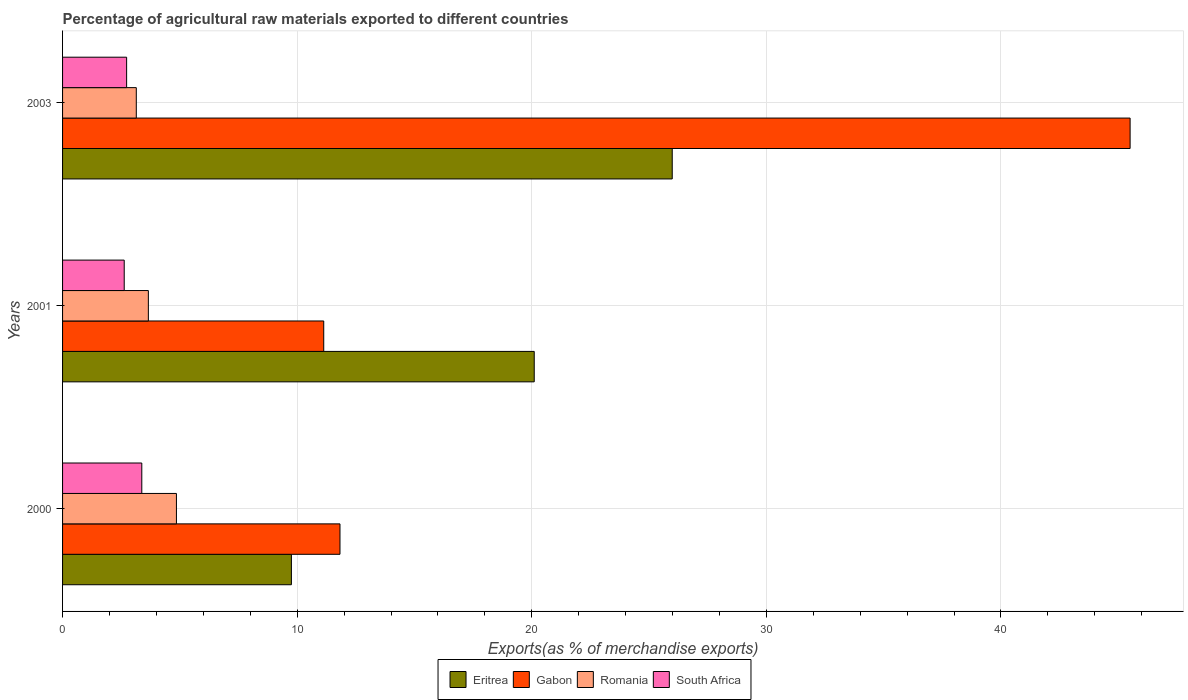How many groups of bars are there?
Give a very brief answer. 3. How many bars are there on the 1st tick from the top?
Your answer should be very brief. 4. How many bars are there on the 1st tick from the bottom?
Offer a very short reply. 4. What is the label of the 3rd group of bars from the top?
Offer a terse response. 2000. In how many cases, is the number of bars for a given year not equal to the number of legend labels?
Offer a very short reply. 0. What is the percentage of exports to different countries in Eritrea in 2000?
Keep it short and to the point. 9.75. Across all years, what is the maximum percentage of exports to different countries in Eritrea?
Keep it short and to the point. 25.99. Across all years, what is the minimum percentage of exports to different countries in Romania?
Ensure brevity in your answer.  3.14. In which year was the percentage of exports to different countries in South Africa minimum?
Your answer should be very brief. 2001. What is the total percentage of exports to different countries in Romania in the graph?
Make the answer very short. 11.65. What is the difference between the percentage of exports to different countries in Romania in 2000 and that in 2003?
Ensure brevity in your answer.  1.71. What is the difference between the percentage of exports to different countries in Eritrea in 2001 and the percentage of exports to different countries in South Africa in 2003?
Provide a short and direct response. 17.37. What is the average percentage of exports to different countries in South Africa per year?
Make the answer very short. 2.91. In the year 2003, what is the difference between the percentage of exports to different countries in Romania and percentage of exports to different countries in Gabon?
Make the answer very short. -42.36. In how many years, is the percentage of exports to different countries in Eritrea greater than 40 %?
Give a very brief answer. 0. What is the ratio of the percentage of exports to different countries in Eritrea in 2001 to that in 2003?
Your answer should be compact. 0.77. Is the percentage of exports to different countries in Romania in 2001 less than that in 2003?
Keep it short and to the point. No. What is the difference between the highest and the second highest percentage of exports to different countries in Romania?
Offer a very short reply. 1.2. What is the difference between the highest and the lowest percentage of exports to different countries in Gabon?
Ensure brevity in your answer.  34.37. Is the sum of the percentage of exports to different countries in Eritrea in 2000 and 2001 greater than the maximum percentage of exports to different countries in Romania across all years?
Give a very brief answer. Yes. Is it the case that in every year, the sum of the percentage of exports to different countries in Eritrea and percentage of exports to different countries in South Africa is greater than the sum of percentage of exports to different countries in Gabon and percentage of exports to different countries in Romania?
Your response must be concise. No. What does the 4th bar from the top in 2000 represents?
Your answer should be very brief. Eritrea. What does the 4th bar from the bottom in 2003 represents?
Ensure brevity in your answer.  South Africa. Is it the case that in every year, the sum of the percentage of exports to different countries in South Africa and percentage of exports to different countries in Romania is greater than the percentage of exports to different countries in Eritrea?
Offer a terse response. No. How many bars are there?
Provide a short and direct response. 12. How many years are there in the graph?
Ensure brevity in your answer.  3. Where does the legend appear in the graph?
Provide a succinct answer. Bottom center. How many legend labels are there?
Your answer should be very brief. 4. What is the title of the graph?
Your answer should be compact. Percentage of agricultural raw materials exported to different countries. Does "Indonesia" appear as one of the legend labels in the graph?
Give a very brief answer. No. What is the label or title of the X-axis?
Offer a terse response. Exports(as % of merchandise exports). What is the label or title of the Y-axis?
Offer a very short reply. Years. What is the Exports(as % of merchandise exports) of Eritrea in 2000?
Keep it short and to the point. 9.75. What is the Exports(as % of merchandise exports) in Gabon in 2000?
Offer a very short reply. 11.82. What is the Exports(as % of merchandise exports) of Romania in 2000?
Your answer should be compact. 4.85. What is the Exports(as % of merchandise exports) of South Africa in 2000?
Provide a short and direct response. 3.38. What is the Exports(as % of merchandise exports) of Eritrea in 2001?
Your response must be concise. 20.1. What is the Exports(as % of merchandise exports) in Gabon in 2001?
Give a very brief answer. 11.13. What is the Exports(as % of merchandise exports) of Romania in 2001?
Keep it short and to the point. 3.66. What is the Exports(as % of merchandise exports) of South Africa in 2001?
Your answer should be very brief. 2.63. What is the Exports(as % of merchandise exports) of Eritrea in 2003?
Ensure brevity in your answer.  25.99. What is the Exports(as % of merchandise exports) in Gabon in 2003?
Ensure brevity in your answer.  45.5. What is the Exports(as % of merchandise exports) of Romania in 2003?
Provide a short and direct response. 3.14. What is the Exports(as % of merchandise exports) in South Africa in 2003?
Your response must be concise. 2.73. Across all years, what is the maximum Exports(as % of merchandise exports) of Eritrea?
Provide a succinct answer. 25.99. Across all years, what is the maximum Exports(as % of merchandise exports) of Gabon?
Keep it short and to the point. 45.5. Across all years, what is the maximum Exports(as % of merchandise exports) in Romania?
Provide a succinct answer. 4.85. Across all years, what is the maximum Exports(as % of merchandise exports) of South Africa?
Provide a short and direct response. 3.38. Across all years, what is the minimum Exports(as % of merchandise exports) in Eritrea?
Keep it short and to the point. 9.75. Across all years, what is the minimum Exports(as % of merchandise exports) of Gabon?
Provide a succinct answer. 11.13. Across all years, what is the minimum Exports(as % of merchandise exports) in Romania?
Give a very brief answer. 3.14. Across all years, what is the minimum Exports(as % of merchandise exports) in South Africa?
Give a very brief answer. 2.63. What is the total Exports(as % of merchandise exports) in Eritrea in the graph?
Your answer should be compact. 55.85. What is the total Exports(as % of merchandise exports) in Gabon in the graph?
Your response must be concise. 68.46. What is the total Exports(as % of merchandise exports) of Romania in the graph?
Ensure brevity in your answer.  11.65. What is the total Exports(as % of merchandise exports) of South Africa in the graph?
Give a very brief answer. 8.74. What is the difference between the Exports(as % of merchandise exports) in Eritrea in 2000 and that in 2001?
Give a very brief answer. -10.35. What is the difference between the Exports(as % of merchandise exports) of Gabon in 2000 and that in 2001?
Provide a short and direct response. 0.69. What is the difference between the Exports(as % of merchandise exports) in Romania in 2000 and that in 2001?
Offer a terse response. 1.2. What is the difference between the Exports(as % of merchandise exports) of South Africa in 2000 and that in 2001?
Make the answer very short. 0.75. What is the difference between the Exports(as % of merchandise exports) of Eritrea in 2000 and that in 2003?
Your answer should be very brief. -16.23. What is the difference between the Exports(as % of merchandise exports) of Gabon in 2000 and that in 2003?
Your response must be concise. -33.68. What is the difference between the Exports(as % of merchandise exports) of Romania in 2000 and that in 2003?
Keep it short and to the point. 1.71. What is the difference between the Exports(as % of merchandise exports) in South Africa in 2000 and that in 2003?
Give a very brief answer. 0.65. What is the difference between the Exports(as % of merchandise exports) in Eritrea in 2001 and that in 2003?
Ensure brevity in your answer.  -5.88. What is the difference between the Exports(as % of merchandise exports) of Gabon in 2001 and that in 2003?
Your answer should be compact. -34.37. What is the difference between the Exports(as % of merchandise exports) of Romania in 2001 and that in 2003?
Keep it short and to the point. 0.51. What is the difference between the Exports(as % of merchandise exports) of South Africa in 2001 and that in 2003?
Offer a terse response. -0.1. What is the difference between the Exports(as % of merchandise exports) in Eritrea in 2000 and the Exports(as % of merchandise exports) in Gabon in 2001?
Ensure brevity in your answer.  -1.38. What is the difference between the Exports(as % of merchandise exports) in Eritrea in 2000 and the Exports(as % of merchandise exports) in Romania in 2001?
Your answer should be very brief. 6.1. What is the difference between the Exports(as % of merchandise exports) in Eritrea in 2000 and the Exports(as % of merchandise exports) in South Africa in 2001?
Your response must be concise. 7.13. What is the difference between the Exports(as % of merchandise exports) in Gabon in 2000 and the Exports(as % of merchandise exports) in Romania in 2001?
Your response must be concise. 8.17. What is the difference between the Exports(as % of merchandise exports) of Gabon in 2000 and the Exports(as % of merchandise exports) of South Africa in 2001?
Ensure brevity in your answer.  9.2. What is the difference between the Exports(as % of merchandise exports) of Romania in 2000 and the Exports(as % of merchandise exports) of South Africa in 2001?
Offer a very short reply. 2.23. What is the difference between the Exports(as % of merchandise exports) in Eritrea in 2000 and the Exports(as % of merchandise exports) in Gabon in 2003?
Your response must be concise. -35.75. What is the difference between the Exports(as % of merchandise exports) of Eritrea in 2000 and the Exports(as % of merchandise exports) of Romania in 2003?
Your response must be concise. 6.61. What is the difference between the Exports(as % of merchandise exports) in Eritrea in 2000 and the Exports(as % of merchandise exports) in South Africa in 2003?
Make the answer very short. 7.02. What is the difference between the Exports(as % of merchandise exports) in Gabon in 2000 and the Exports(as % of merchandise exports) in Romania in 2003?
Keep it short and to the point. 8.68. What is the difference between the Exports(as % of merchandise exports) of Gabon in 2000 and the Exports(as % of merchandise exports) of South Africa in 2003?
Offer a terse response. 9.09. What is the difference between the Exports(as % of merchandise exports) in Romania in 2000 and the Exports(as % of merchandise exports) in South Africa in 2003?
Provide a short and direct response. 2.12. What is the difference between the Exports(as % of merchandise exports) of Eritrea in 2001 and the Exports(as % of merchandise exports) of Gabon in 2003?
Make the answer very short. -25.4. What is the difference between the Exports(as % of merchandise exports) in Eritrea in 2001 and the Exports(as % of merchandise exports) in Romania in 2003?
Offer a terse response. 16.96. What is the difference between the Exports(as % of merchandise exports) of Eritrea in 2001 and the Exports(as % of merchandise exports) of South Africa in 2003?
Offer a terse response. 17.37. What is the difference between the Exports(as % of merchandise exports) in Gabon in 2001 and the Exports(as % of merchandise exports) in Romania in 2003?
Provide a succinct answer. 7.99. What is the difference between the Exports(as % of merchandise exports) in Gabon in 2001 and the Exports(as % of merchandise exports) in South Africa in 2003?
Your answer should be compact. 8.4. What is the difference between the Exports(as % of merchandise exports) of Romania in 2001 and the Exports(as % of merchandise exports) of South Africa in 2003?
Keep it short and to the point. 0.93. What is the average Exports(as % of merchandise exports) of Eritrea per year?
Your response must be concise. 18.62. What is the average Exports(as % of merchandise exports) in Gabon per year?
Provide a succinct answer. 22.82. What is the average Exports(as % of merchandise exports) of Romania per year?
Make the answer very short. 3.88. What is the average Exports(as % of merchandise exports) in South Africa per year?
Give a very brief answer. 2.91. In the year 2000, what is the difference between the Exports(as % of merchandise exports) in Eritrea and Exports(as % of merchandise exports) in Gabon?
Provide a succinct answer. -2.07. In the year 2000, what is the difference between the Exports(as % of merchandise exports) of Eritrea and Exports(as % of merchandise exports) of Romania?
Make the answer very short. 4.9. In the year 2000, what is the difference between the Exports(as % of merchandise exports) of Eritrea and Exports(as % of merchandise exports) of South Africa?
Provide a short and direct response. 6.38. In the year 2000, what is the difference between the Exports(as % of merchandise exports) of Gabon and Exports(as % of merchandise exports) of Romania?
Provide a short and direct response. 6.97. In the year 2000, what is the difference between the Exports(as % of merchandise exports) in Gabon and Exports(as % of merchandise exports) in South Africa?
Ensure brevity in your answer.  8.45. In the year 2000, what is the difference between the Exports(as % of merchandise exports) in Romania and Exports(as % of merchandise exports) in South Africa?
Your response must be concise. 1.48. In the year 2001, what is the difference between the Exports(as % of merchandise exports) in Eritrea and Exports(as % of merchandise exports) in Gabon?
Your response must be concise. 8.97. In the year 2001, what is the difference between the Exports(as % of merchandise exports) of Eritrea and Exports(as % of merchandise exports) of Romania?
Keep it short and to the point. 16.45. In the year 2001, what is the difference between the Exports(as % of merchandise exports) of Eritrea and Exports(as % of merchandise exports) of South Africa?
Your response must be concise. 17.48. In the year 2001, what is the difference between the Exports(as % of merchandise exports) of Gabon and Exports(as % of merchandise exports) of Romania?
Offer a very short reply. 7.48. In the year 2001, what is the difference between the Exports(as % of merchandise exports) in Gabon and Exports(as % of merchandise exports) in South Africa?
Your response must be concise. 8.5. In the year 2001, what is the difference between the Exports(as % of merchandise exports) in Romania and Exports(as % of merchandise exports) in South Africa?
Your response must be concise. 1.03. In the year 2003, what is the difference between the Exports(as % of merchandise exports) in Eritrea and Exports(as % of merchandise exports) in Gabon?
Your answer should be compact. -19.52. In the year 2003, what is the difference between the Exports(as % of merchandise exports) in Eritrea and Exports(as % of merchandise exports) in Romania?
Keep it short and to the point. 22.84. In the year 2003, what is the difference between the Exports(as % of merchandise exports) in Eritrea and Exports(as % of merchandise exports) in South Africa?
Your answer should be compact. 23.26. In the year 2003, what is the difference between the Exports(as % of merchandise exports) in Gabon and Exports(as % of merchandise exports) in Romania?
Provide a short and direct response. 42.36. In the year 2003, what is the difference between the Exports(as % of merchandise exports) of Gabon and Exports(as % of merchandise exports) of South Africa?
Offer a terse response. 42.77. In the year 2003, what is the difference between the Exports(as % of merchandise exports) in Romania and Exports(as % of merchandise exports) in South Africa?
Offer a terse response. 0.41. What is the ratio of the Exports(as % of merchandise exports) of Eritrea in 2000 to that in 2001?
Provide a short and direct response. 0.49. What is the ratio of the Exports(as % of merchandise exports) of Gabon in 2000 to that in 2001?
Provide a succinct answer. 1.06. What is the ratio of the Exports(as % of merchandise exports) in Romania in 2000 to that in 2001?
Offer a very short reply. 1.33. What is the ratio of the Exports(as % of merchandise exports) of South Africa in 2000 to that in 2001?
Your answer should be compact. 1.29. What is the ratio of the Exports(as % of merchandise exports) of Eritrea in 2000 to that in 2003?
Offer a very short reply. 0.38. What is the ratio of the Exports(as % of merchandise exports) of Gabon in 2000 to that in 2003?
Your response must be concise. 0.26. What is the ratio of the Exports(as % of merchandise exports) of Romania in 2000 to that in 2003?
Keep it short and to the point. 1.54. What is the ratio of the Exports(as % of merchandise exports) of South Africa in 2000 to that in 2003?
Give a very brief answer. 1.24. What is the ratio of the Exports(as % of merchandise exports) in Eritrea in 2001 to that in 2003?
Make the answer very short. 0.77. What is the ratio of the Exports(as % of merchandise exports) in Gabon in 2001 to that in 2003?
Give a very brief answer. 0.24. What is the ratio of the Exports(as % of merchandise exports) in Romania in 2001 to that in 2003?
Make the answer very short. 1.16. What is the ratio of the Exports(as % of merchandise exports) of South Africa in 2001 to that in 2003?
Your answer should be very brief. 0.96. What is the difference between the highest and the second highest Exports(as % of merchandise exports) in Eritrea?
Provide a succinct answer. 5.88. What is the difference between the highest and the second highest Exports(as % of merchandise exports) of Gabon?
Give a very brief answer. 33.68. What is the difference between the highest and the second highest Exports(as % of merchandise exports) in Romania?
Offer a very short reply. 1.2. What is the difference between the highest and the second highest Exports(as % of merchandise exports) of South Africa?
Ensure brevity in your answer.  0.65. What is the difference between the highest and the lowest Exports(as % of merchandise exports) of Eritrea?
Provide a short and direct response. 16.23. What is the difference between the highest and the lowest Exports(as % of merchandise exports) in Gabon?
Provide a short and direct response. 34.37. What is the difference between the highest and the lowest Exports(as % of merchandise exports) of Romania?
Offer a very short reply. 1.71. What is the difference between the highest and the lowest Exports(as % of merchandise exports) of South Africa?
Provide a short and direct response. 0.75. 